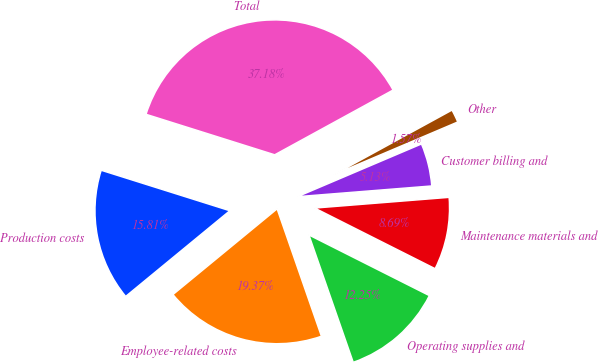<chart> <loc_0><loc_0><loc_500><loc_500><pie_chart><fcel>Production costs<fcel>Employee-related costs<fcel>Operating supplies and<fcel>Maintenance materials and<fcel>Customer billing and<fcel>Other<fcel>Total<nl><fcel>15.81%<fcel>19.37%<fcel>12.25%<fcel>8.69%<fcel>5.13%<fcel>1.57%<fcel>37.18%<nl></chart> 